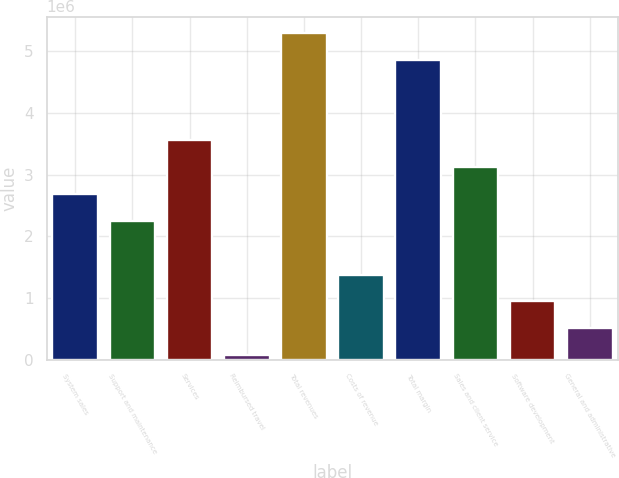Convert chart to OTSL. <chart><loc_0><loc_0><loc_500><loc_500><bar_chart><fcel>System sales<fcel>Support and maintenance<fcel>Services<fcel>Reimbursed travel<fcel>Total revenues<fcel>Costs of revenue<fcel>Total margin<fcel>Sales and client service<fcel>Software development<fcel>General and administrative<nl><fcel>2.68428e+06<fcel>2.24903e+06<fcel>3.55477e+06<fcel>72802<fcel>5.29576e+06<fcel>1.37854e+06<fcel>4.86051e+06<fcel>3.11953e+06<fcel>943295<fcel>508048<nl></chart> 